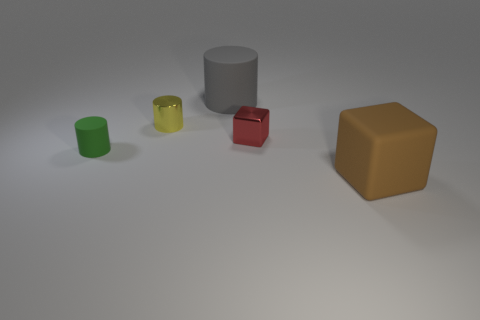Subtract all metallic cylinders. How many cylinders are left? 2 Subtract 2 blocks. How many blocks are left? 0 Subtract all green cylinders. How many cylinders are left? 2 Add 2 big brown rubber cylinders. How many objects exist? 7 Subtract all blocks. How many objects are left? 3 Subtract all brown cubes. Subtract all blue cylinders. How many cubes are left? 1 Subtract all yellow cubes. How many blue cylinders are left? 0 Subtract all purple metallic cubes. Subtract all blocks. How many objects are left? 3 Add 4 large brown rubber objects. How many large brown rubber objects are left? 5 Add 1 large yellow blocks. How many large yellow blocks exist? 1 